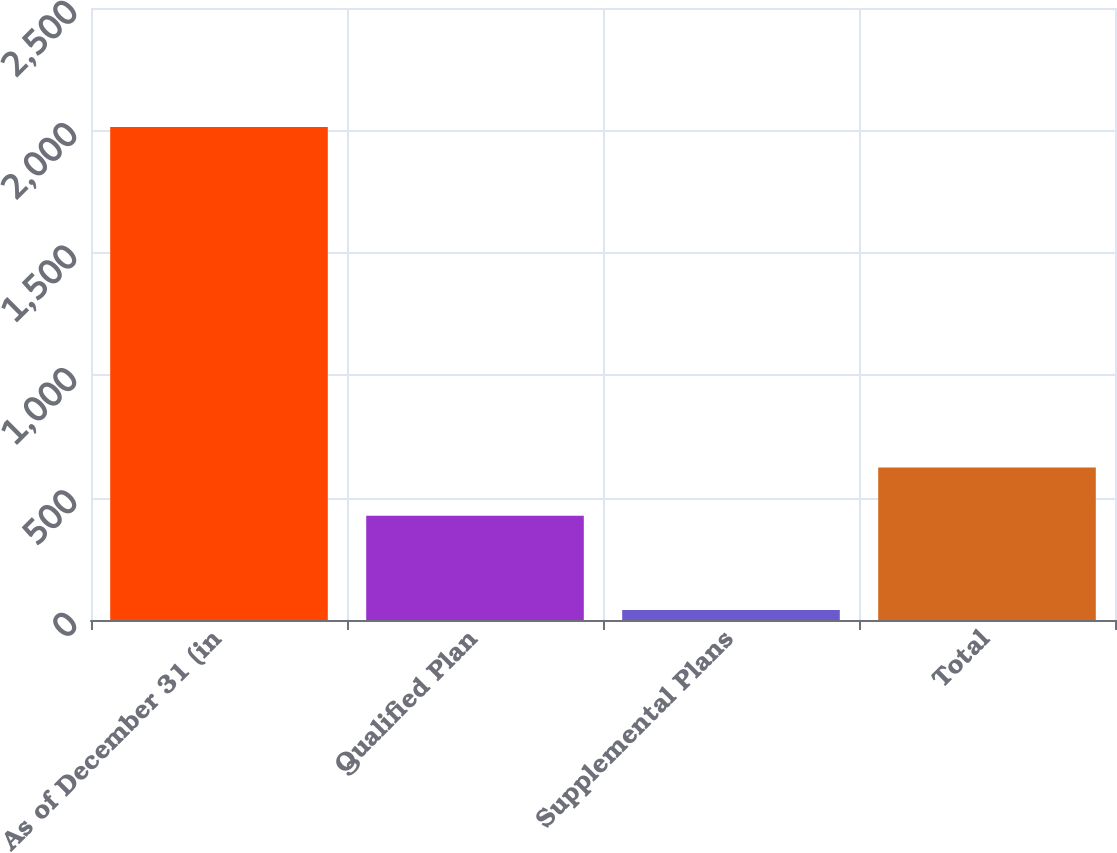Convert chart. <chart><loc_0><loc_0><loc_500><loc_500><bar_chart><fcel>As of December 31 (in<fcel>Qualified Plan<fcel>Supplemental Plans<fcel>Total<nl><fcel>2014<fcel>425.9<fcel>40.5<fcel>623.25<nl></chart> 